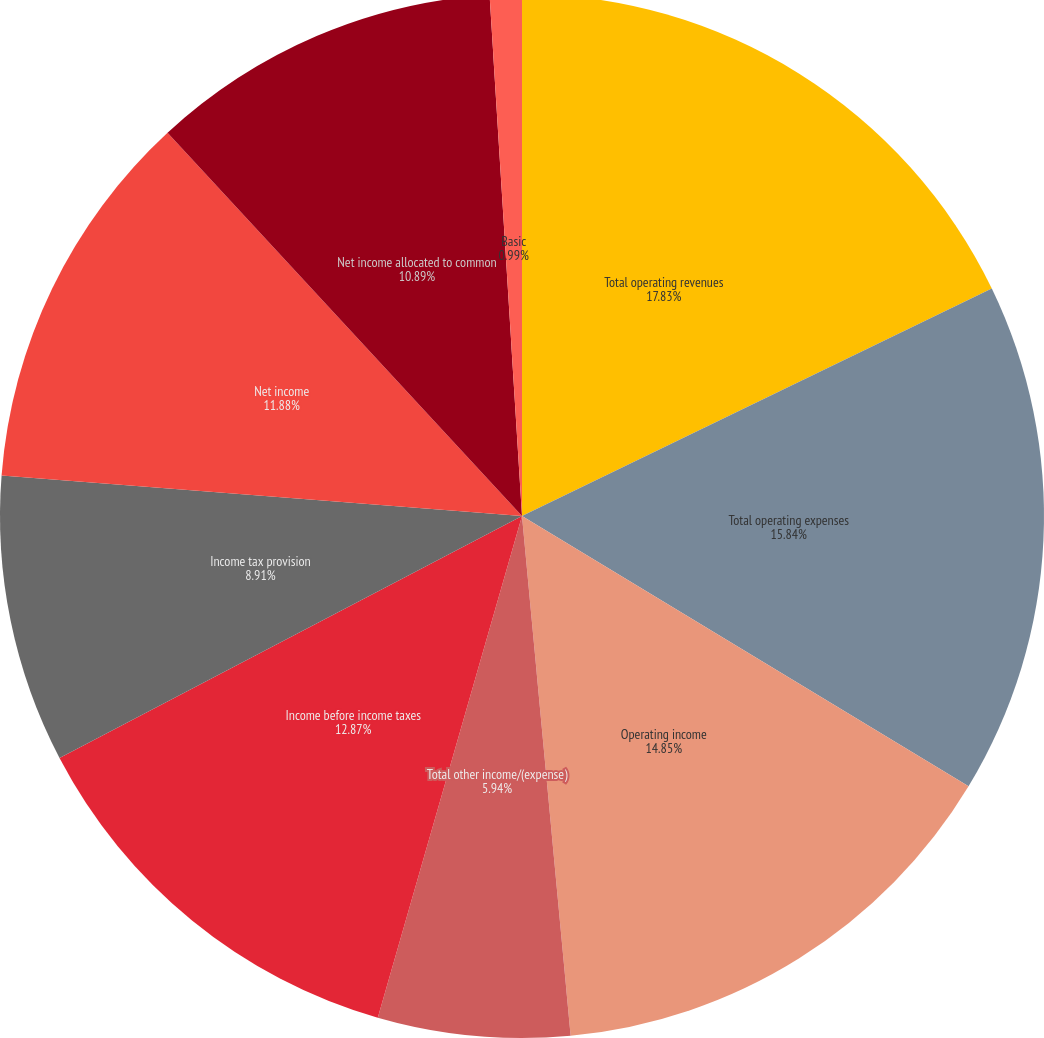Convert chart to OTSL. <chart><loc_0><loc_0><loc_500><loc_500><pie_chart><fcel>Total operating revenues<fcel>Total operating expenses<fcel>Operating income<fcel>Total other income/(expense)<fcel>Income before income taxes<fcel>Income tax provision<fcel>Net income<fcel>Net income allocated to common<fcel>Basic<fcel>Cash dividends declared per<nl><fcel>17.82%<fcel>15.84%<fcel>14.85%<fcel>5.94%<fcel>12.87%<fcel>8.91%<fcel>11.88%<fcel>10.89%<fcel>0.99%<fcel>0.0%<nl></chart> 